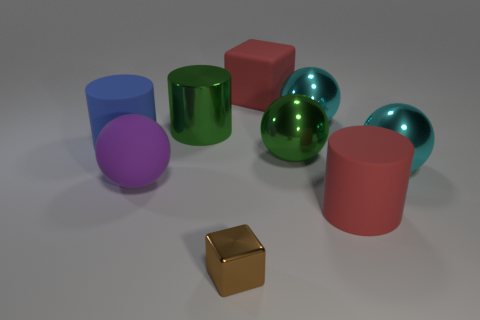Subtract all large green cylinders. How many cylinders are left? 2 Subtract all brown cubes. How many cubes are left? 1 Add 1 cyan spheres. How many objects exist? 10 Subtract all yellow spheres. How many green cylinders are left? 1 Subtract all blocks. How many objects are left? 7 Subtract 3 cylinders. How many cylinders are left? 0 Subtract all red blocks. Subtract all purple balls. How many blocks are left? 1 Subtract all red blocks. Subtract all blue rubber objects. How many objects are left? 7 Add 8 blue rubber cylinders. How many blue rubber cylinders are left? 9 Add 9 large green shiny cylinders. How many large green shiny cylinders exist? 10 